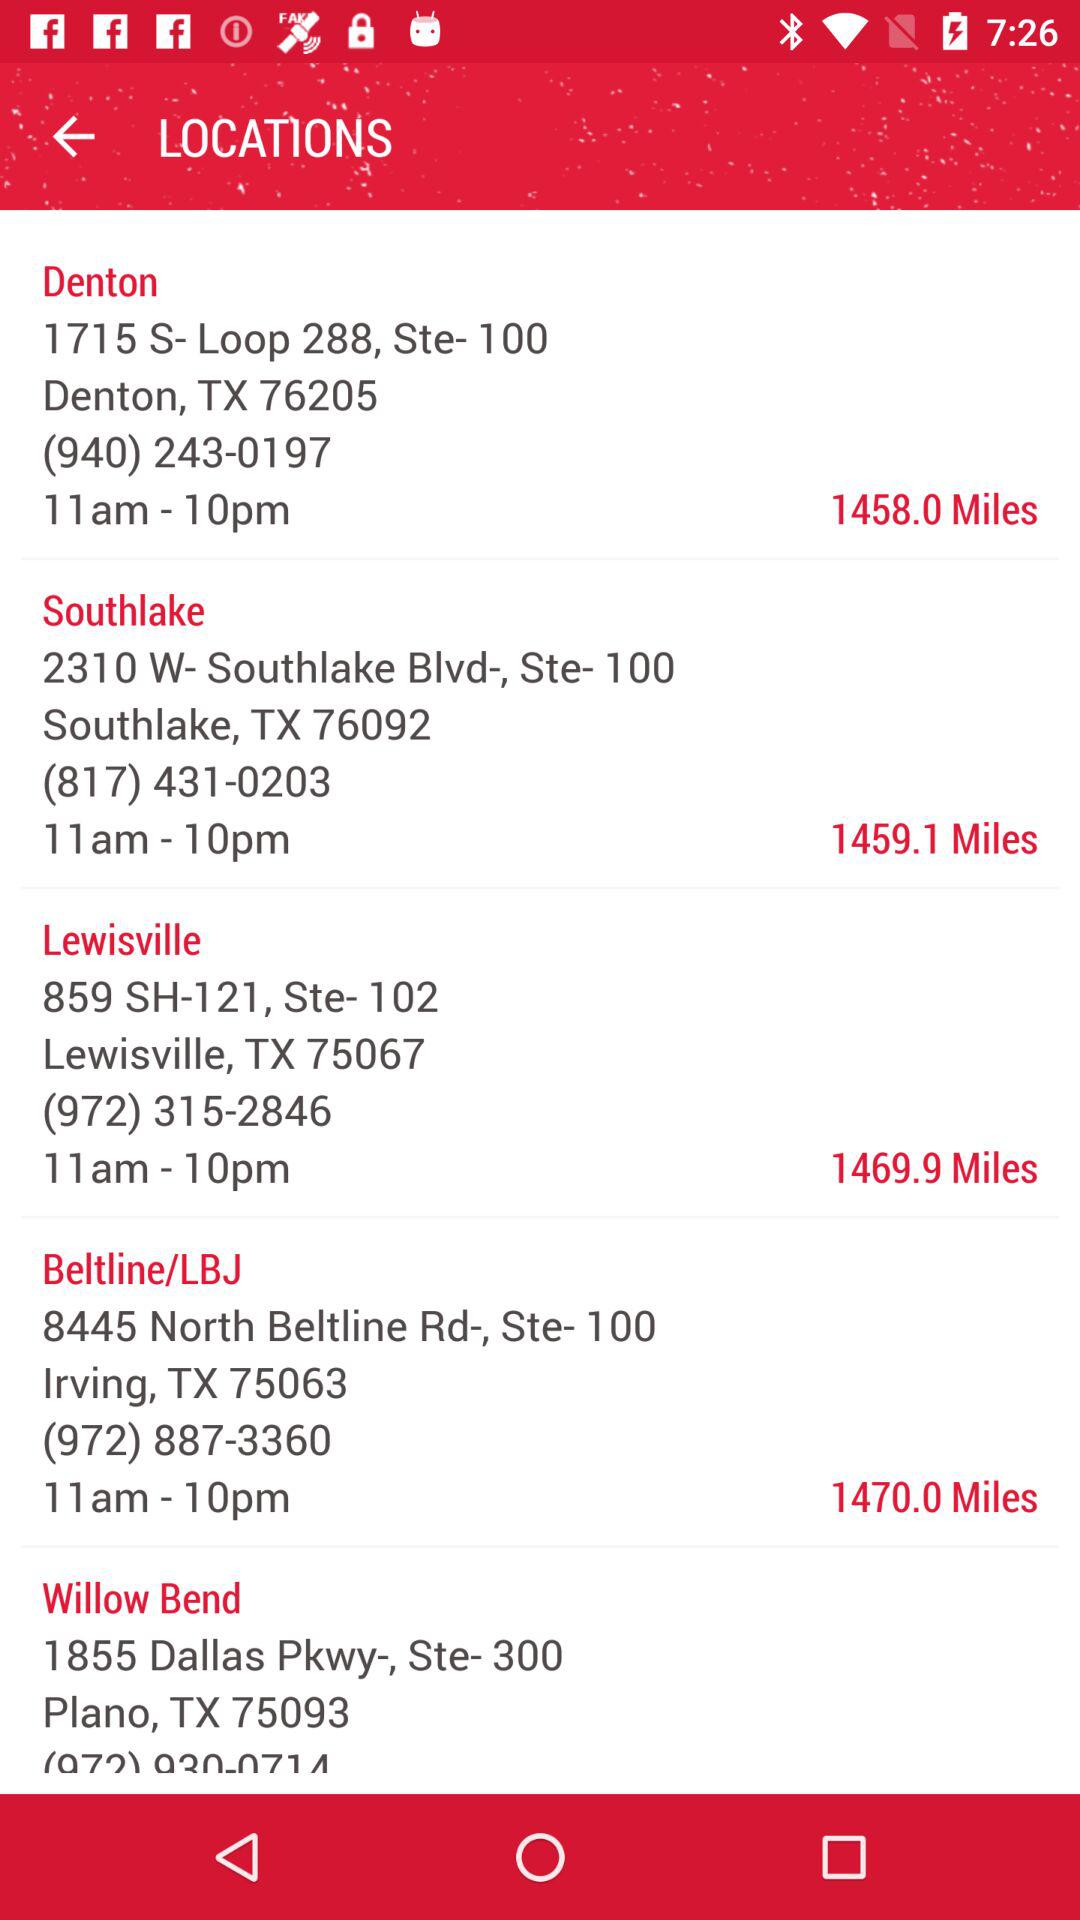What is the address of Southlake? The address is 2310 W-Southlake Blvd-, Ste- 100, Southlake, TX 76092. 